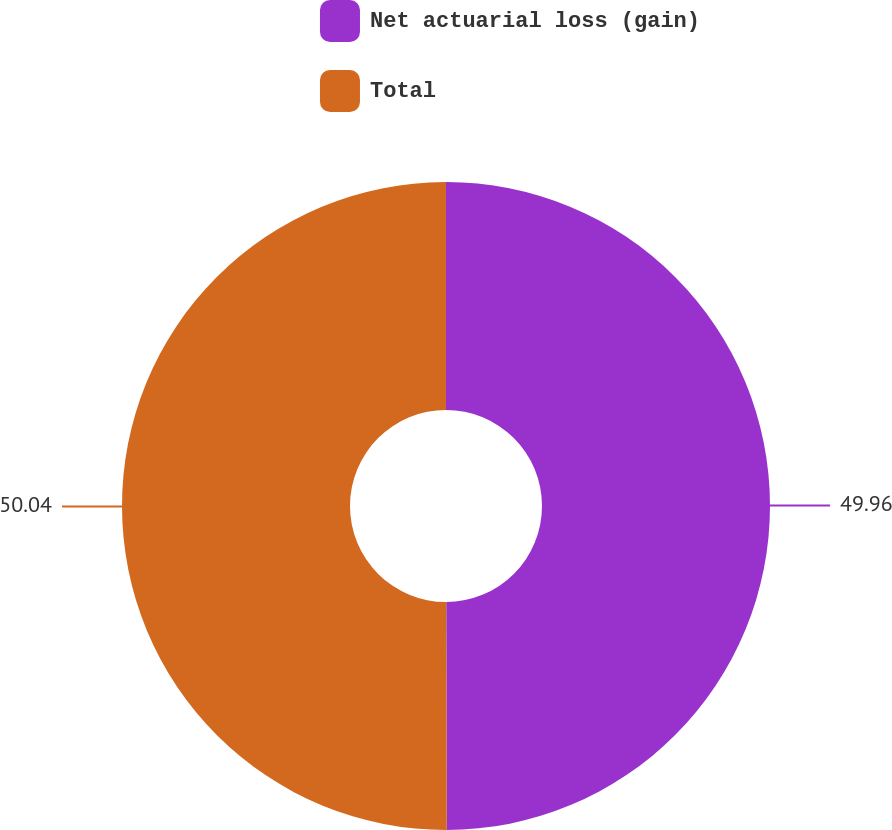Convert chart to OTSL. <chart><loc_0><loc_0><loc_500><loc_500><pie_chart><fcel>Net actuarial loss (gain)<fcel>Total<nl><fcel>49.96%<fcel>50.04%<nl></chart> 